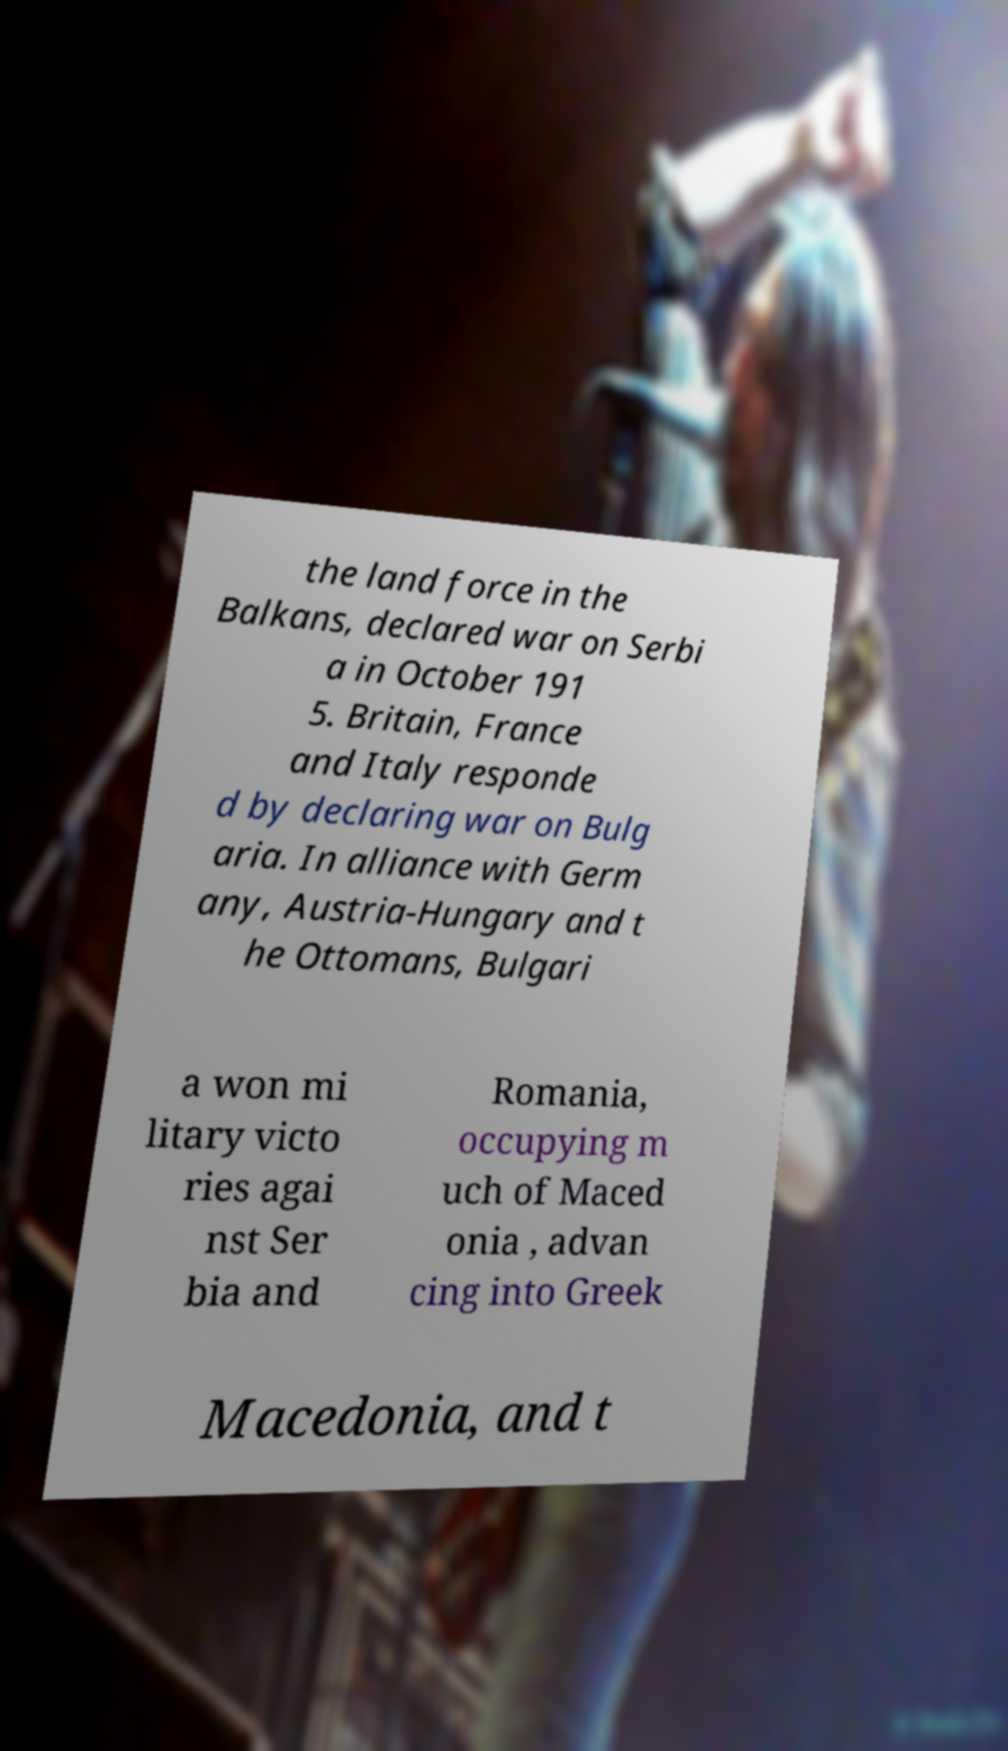I need the written content from this picture converted into text. Can you do that? the land force in the Balkans, declared war on Serbi a in October 191 5. Britain, France and Italy responde d by declaring war on Bulg aria. In alliance with Germ any, Austria-Hungary and t he Ottomans, Bulgari a won mi litary victo ries agai nst Ser bia and Romania, occupying m uch of Maced onia , advan cing into Greek Macedonia, and t 